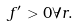<formula> <loc_0><loc_0><loc_500><loc_500>f ^ { \prime } > 0 \forall r .</formula> 